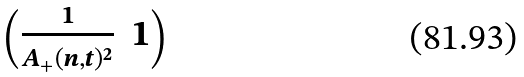Convert formula to latex. <formula><loc_0><loc_0><loc_500><loc_500>\begin{pmatrix} \frac { 1 } { A _ { + } ( n , t ) ^ { 2 } } & 1 \end{pmatrix}</formula> 